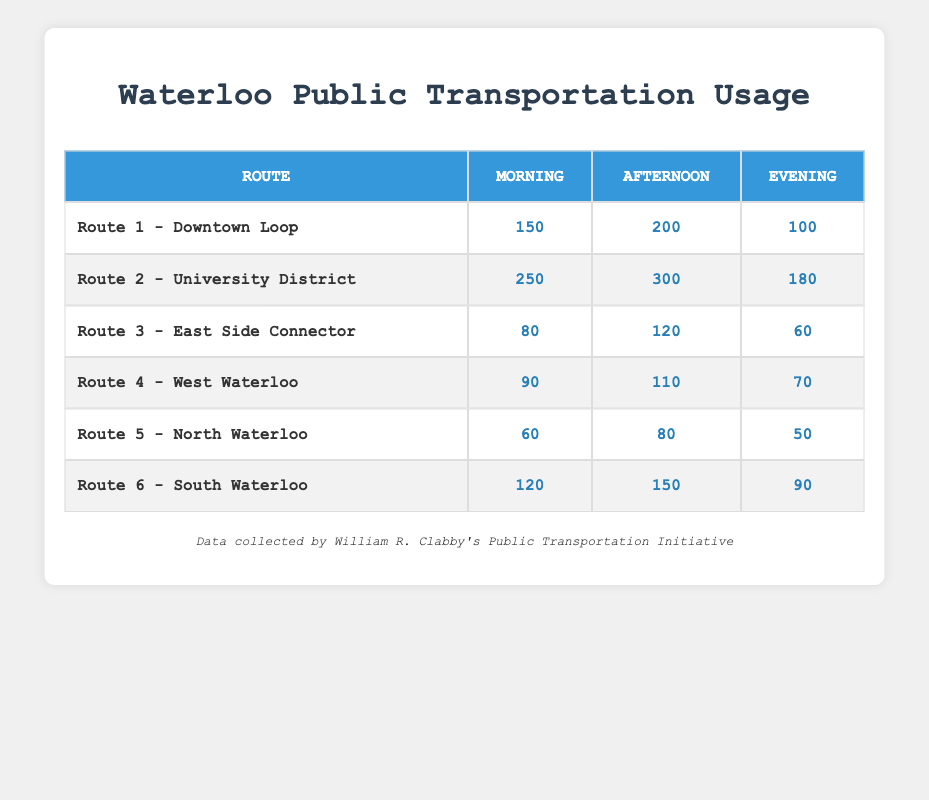What is the ridership for Route 2 in the Afternoon? According to the table, the ridership for Route 2 - University District during the Afternoon is listed directly in the cell corresponding to that route and time.
Answer: 300 Which route has the highest morning ridership? Reviewing the Morning ridership values, Route 2 - University District has the highest value of 250, while other routes have lower ridership numbers.
Answer: Route 2 - University District What is the total ridership for Route 5 across all time periods? To calculate the total ridership for Route 5, we sum the values for Morning (60), Afternoon (80), and Evening (50): 60 + 80 + 50 = 190.
Answer: 190 How does the Evening ridership for Route 6 compare to Route 3? The Evening ridership for Route 6 is 90, while for Route 3 it is 60. Since 90 is greater than 60, Route 6 has higher ridership in the Evening.
Answer: Route 6 has higher ridership Is the Afternoon ridership for Route 4 greater than the Morning ridership for Route 1? The Afternoon ridership for Route 4 is 110, and the Morning ridership for Route 1 is 150. Since 110 is less than 150, this statement is false.
Answer: No What is the average Evening ridership for all routes combined? To find the average Evening ridership, we first sum the Evening values for each route: 100 (Route 1) + 180 (Route 2) + 60 (Route 3) + 70 (Route 4) + 50 (Route 5) + 90 (Route 6) = 550. There are 6 routes, so the average is 550 / 6 = approximately 91.67.
Answer: Approximately 91.67 Which route has the lowest overall ridership across all time periods? We can check the total ridership for each route. The totals are: Route 1 = 450, Route 2 = 730, Route 3 = 260, Route 4 = 270, Route 5 = 190, and Route 6 = 360. Route 5 has the lowest total of 190.
Answer: Route 5 - North Waterloo What is the difference in ridership between the Afternoon and Evening for Route 2? The Afternoon ridership for Route 2 is 300, and the Evening ridership is 180. To find the difference, we subtract the Evening from the Afternoon: 300 - 180 = 120.
Answer: 120 How does the total ridership of Route 1 compare to Route 6? Route 1 has a total ridership of 450 (150 + 200 + 100) and Route 6 has a total of 360 (120 + 150 + 90). Since 450 is greater than 360, Route 1 has higher total ridership.
Answer: Route 1 has higher ridership 